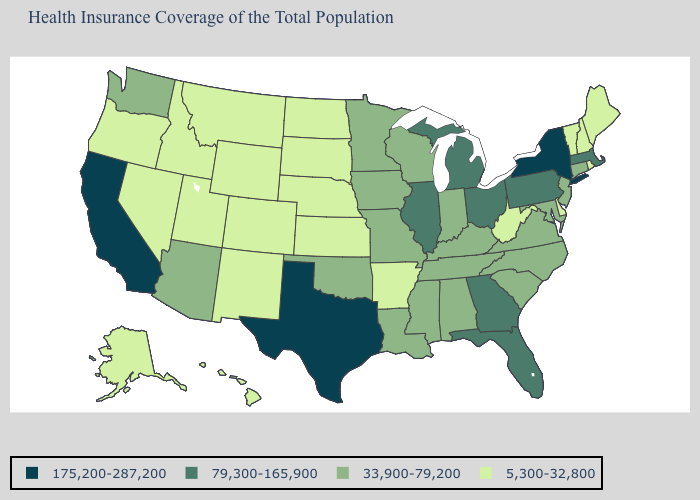What is the highest value in states that border Nebraska?
Keep it brief. 33,900-79,200. What is the highest value in the South ?
Keep it brief. 175,200-287,200. What is the value of Oregon?
Keep it brief. 5,300-32,800. What is the value of Maryland?
Concise answer only. 33,900-79,200. What is the lowest value in the USA?
Be succinct. 5,300-32,800. What is the value of Florida?
Quick response, please. 79,300-165,900. Does the map have missing data?
Concise answer only. No. What is the value of Florida?
Short answer required. 79,300-165,900. Does New York have the same value as California?
Keep it brief. Yes. Name the states that have a value in the range 5,300-32,800?
Concise answer only. Alaska, Arkansas, Colorado, Delaware, Hawaii, Idaho, Kansas, Maine, Montana, Nebraska, Nevada, New Hampshire, New Mexico, North Dakota, Oregon, Rhode Island, South Dakota, Utah, Vermont, West Virginia, Wyoming. Name the states that have a value in the range 33,900-79,200?
Quick response, please. Alabama, Arizona, Connecticut, Indiana, Iowa, Kentucky, Louisiana, Maryland, Minnesota, Mississippi, Missouri, New Jersey, North Carolina, Oklahoma, South Carolina, Tennessee, Virginia, Washington, Wisconsin. What is the highest value in the USA?
Short answer required. 175,200-287,200. Does Texas have the highest value in the USA?
Concise answer only. Yes. Does Illinois have the lowest value in the MidWest?
Keep it brief. No. What is the value of Tennessee?
Keep it brief. 33,900-79,200. 